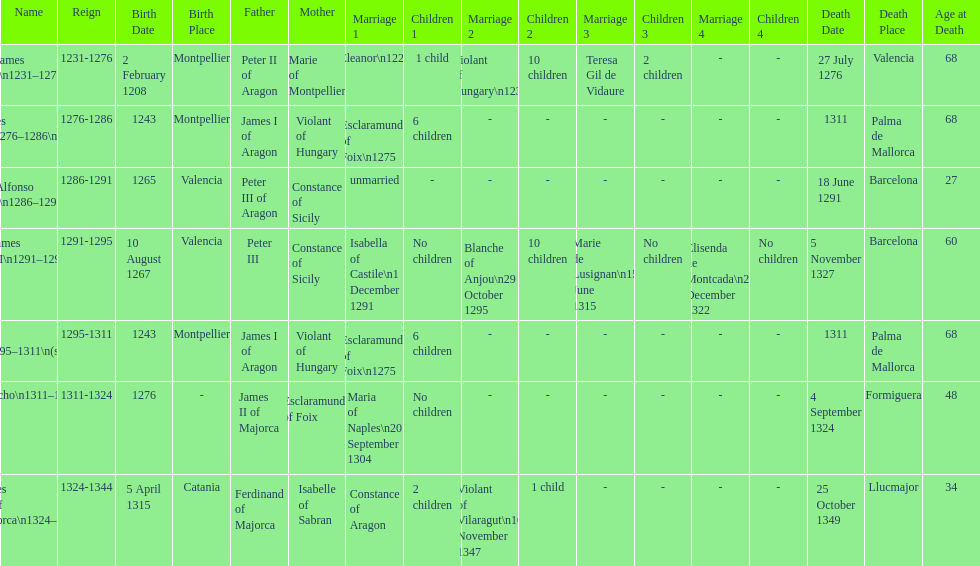What name is above james iii and below james ii? Alfonso I. Would you mind parsing the complete table? {'header': ['Name', 'Reign', 'Birth Date', 'Birth Place', 'Father', 'Mother', 'Marriage 1', 'Children 1', 'Marriage 2', 'Children 2', 'Marriage 3', 'Children 3', 'Marriage 4', 'Children 4', 'Death Date', 'Death Place', 'Age at Death'], 'rows': [['James I\\n1231–1276', '1231-1276', '2 February 1208', 'Montpellier', 'Peter II of Aragon', 'Marie of Montpellier', 'Eleanor\\n1221', '1 child', 'Violant of Hungary\\n1235', '10 children', 'Teresa Gil de Vidaure', '2 children', '-', '-', '27 July 1276', 'Valencia', '68'], ['James II\\n1276–1286\\n(first rule)', '1276-1286', '1243', 'Montpellier', 'James I of Aragon', 'Violant of Hungary', 'Esclaramunda of Foix\\n1275', '6 children', '-', '-', '-', '-', '-', '-', '1311', 'Palma de Mallorca', '68'], ['Alfonso I\\n1286–1291', '1286-1291', '1265', 'Valencia', 'Peter III of Aragon', 'Constance of Sicily', 'unmarried', '-', '-', '-', '-', '-', '-', '-', '18 June 1291', 'Barcelona', '27'], ['James III\\n1291–1295', '1291-1295', '10 August 1267', 'Valencia', 'Peter III', 'Constance of Sicily', 'Isabella of Castile\\n1 December 1291', 'No children', 'Blanche of Anjou\\n29 October 1295', '10 children', 'Marie de Lusignan\\n15 June 1315', 'No children', 'Elisenda de Montcada\\n25 December 1322', 'No children', '5 November 1327', 'Barcelona', '60'], ['James II\\n1295–1311\\n(second rule)', '1295-1311', '1243', 'Montpellier', 'James I of Aragon', 'Violant of Hungary', 'Esclaramunda of Foix\\n1275', '6 children', '-', '-', '-', '-', '-', '-', '1311', 'Palma de Mallorca', '68'], ['Sancho\\n1311–1324', '1311-1324', '1276', '-', 'James II of Majorca', 'Esclaramunda of Foix', 'Maria of Naples\\n20 September 1304', 'No children', '-', '-', '-', '-', '-', '-', '4 September 1324', 'Formiguera', '48'], ['James III of Majorca\\n1324–1344', '1324-1344', '5 April 1315', 'Catania', 'Ferdinand of Majorca', 'Isabelle of Sabran', 'Constance of Aragon', '2 children', 'Violant of Vilaragut\\n10 November 1347', '1 child', '-', '-', '-', '-', '25 October 1349', 'Llucmajor', '34']]} 